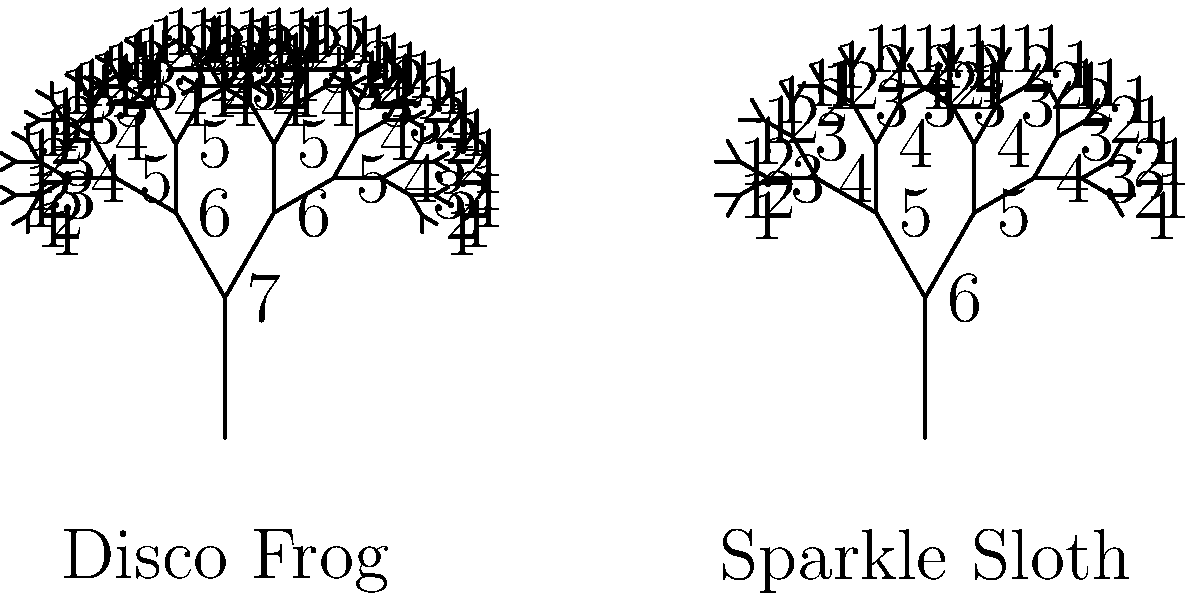Compare the taxonomic hierarchies of the whimsically named "Disco Frog" and "Sparkle Sloth" using the tree diagrams provided. How many levels of classification do these two species share before diverging? To determine how many levels of classification the "Disco Frog" and "Sparkle Sloth" share before diverging, we need to analyze the tree diagrams:

1. Count the levels in each tree:
   - Disco Frog: 7 levels
   - Sparkle Sloth: 6 levels

2. Start from the root (bottom) of both trees and compare levels:
   Level 1: Kingdom (shared)
   Level 2: Phylum (shared)
   Level 3: Class (shared)
   Level 4: Order (diverge)

3. The trees diverge at level 4, which means they share the first 3 levels of classification.

4. These shared levels likely represent:
   Level 1: Kingdom Animalia
   Level 2: Phylum Chordata
   Level 3: Class Vertebrata

5. They diverge at Order because frogs belong to Order Anura, while sloths belong to Order Pilosa.

Therefore, the "Disco Frog" and "Sparkle Sloth" share 3 levels of classification before diverging.
Answer: 3 levels 